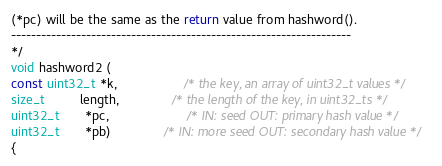Convert code to text. <code><loc_0><loc_0><loc_500><loc_500><_C_>(*pc) will be the same as the return value from hashword().
--------------------------------------------------------------------
*/
void hashword2 (
const uint32_t *k,                   /* the key, an array of uint32_t values */
size_t          length,               /* the length of the key, in uint32_ts */
uint32_t       *pc,                      /* IN: seed OUT: primary hash value */
uint32_t       *pb)               /* IN: more seed OUT: secondary hash value */
{</code> 